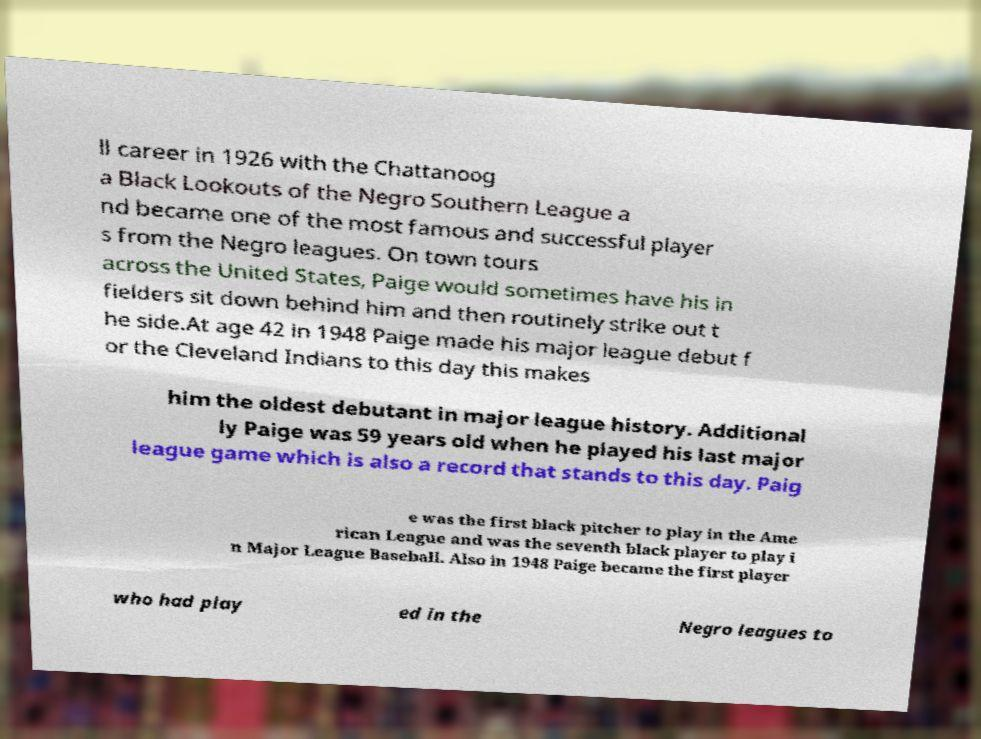Can you accurately transcribe the text from the provided image for me? ll career in 1926 with the Chattanoog a Black Lookouts of the Negro Southern League a nd became one of the most famous and successful player s from the Negro leagues. On town tours across the United States, Paige would sometimes have his in fielders sit down behind him and then routinely strike out t he side.At age 42 in 1948 Paige made his major league debut f or the Cleveland Indians to this day this makes him the oldest debutant in major league history. Additional ly Paige was 59 years old when he played his last major league game which is also a record that stands to this day. Paig e was the first black pitcher to play in the Ame rican League and was the seventh black player to play i n Major League Baseball. Also in 1948 Paige became the first player who had play ed in the Negro leagues to 